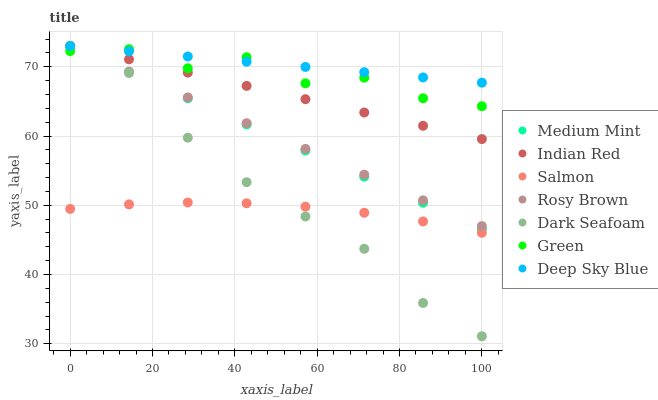Does Salmon have the minimum area under the curve?
Answer yes or no. Yes. Does Deep Sky Blue have the maximum area under the curve?
Answer yes or no. Yes. Does Rosy Brown have the minimum area under the curve?
Answer yes or no. No. Does Rosy Brown have the maximum area under the curve?
Answer yes or no. No. Is Rosy Brown the smoothest?
Answer yes or no. Yes. Is Green the roughest?
Answer yes or no. Yes. Is Deep Sky Blue the smoothest?
Answer yes or no. No. Is Deep Sky Blue the roughest?
Answer yes or no. No. Does Dark Seafoam have the lowest value?
Answer yes or no. Yes. Does Rosy Brown have the lowest value?
Answer yes or no. No. Does Indian Red have the highest value?
Answer yes or no. Yes. Does Salmon have the highest value?
Answer yes or no. No. Is Salmon less than Indian Red?
Answer yes or no. Yes. Is Rosy Brown greater than Salmon?
Answer yes or no. Yes. Does Indian Red intersect Deep Sky Blue?
Answer yes or no. Yes. Is Indian Red less than Deep Sky Blue?
Answer yes or no. No. Is Indian Red greater than Deep Sky Blue?
Answer yes or no. No. Does Salmon intersect Indian Red?
Answer yes or no. No. 